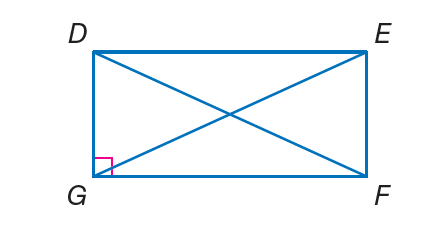Answer the mathemtical geometry problem and directly provide the correct option letter.
Question: Quadrilateral D E F G is a rectangle. If F D = 3 x - 7 and E G = x + 5, find E G.
Choices: A: 6 B: 12 C: 34 D: 56 A 